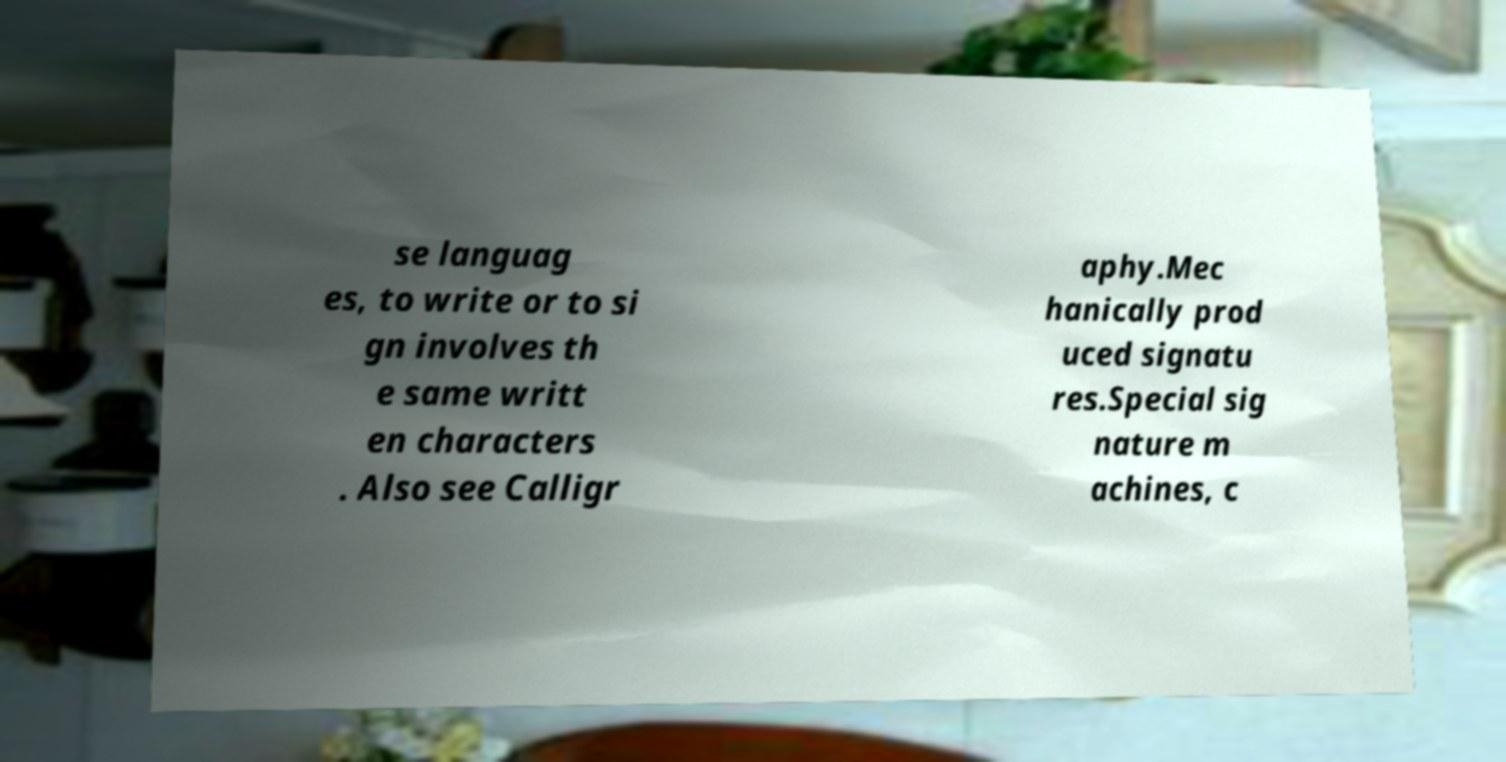For documentation purposes, I need the text within this image transcribed. Could you provide that? se languag es, to write or to si gn involves th e same writt en characters . Also see Calligr aphy.Mec hanically prod uced signatu res.Special sig nature m achines, c 